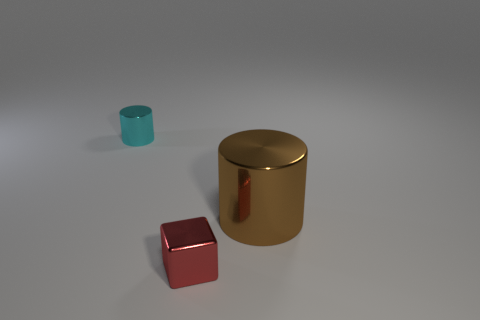Add 2 red cubes. How many objects exist? 5 Subtract all cyan cylinders. How many cylinders are left? 1 Subtract all cylinders. How many objects are left? 1 Subtract 1 blocks. How many blocks are left? 0 Subtract all yellow cylinders. Subtract all red cubes. How many cylinders are left? 2 Subtract all cyan spheres. How many cyan cylinders are left? 1 Subtract all blue objects. Subtract all red blocks. How many objects are left? 2 Add 3 small shiny cylinders. How many small shiny cylinders are left? 4 Add 1 cyan objects. How many cyan objects exist? 2 Subtract 0 yellow spheres. How many objects are left? 3 